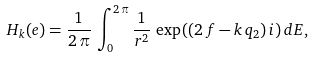Convert formula to latex. <formula><loc_0><loc_0><loc_500><loc_500>H _ { k } ( e ) = \frac { 1 } { 2 \, \pi } \, \int _ { 0 } ^ { 2 \, \pi } { \frac { 1 } { r ^ { 2 } } \, \exp { ( ( 2 \, f - k \, { q _ { 2 } } ) \, i } ) } \, { d E } ,</formula> 